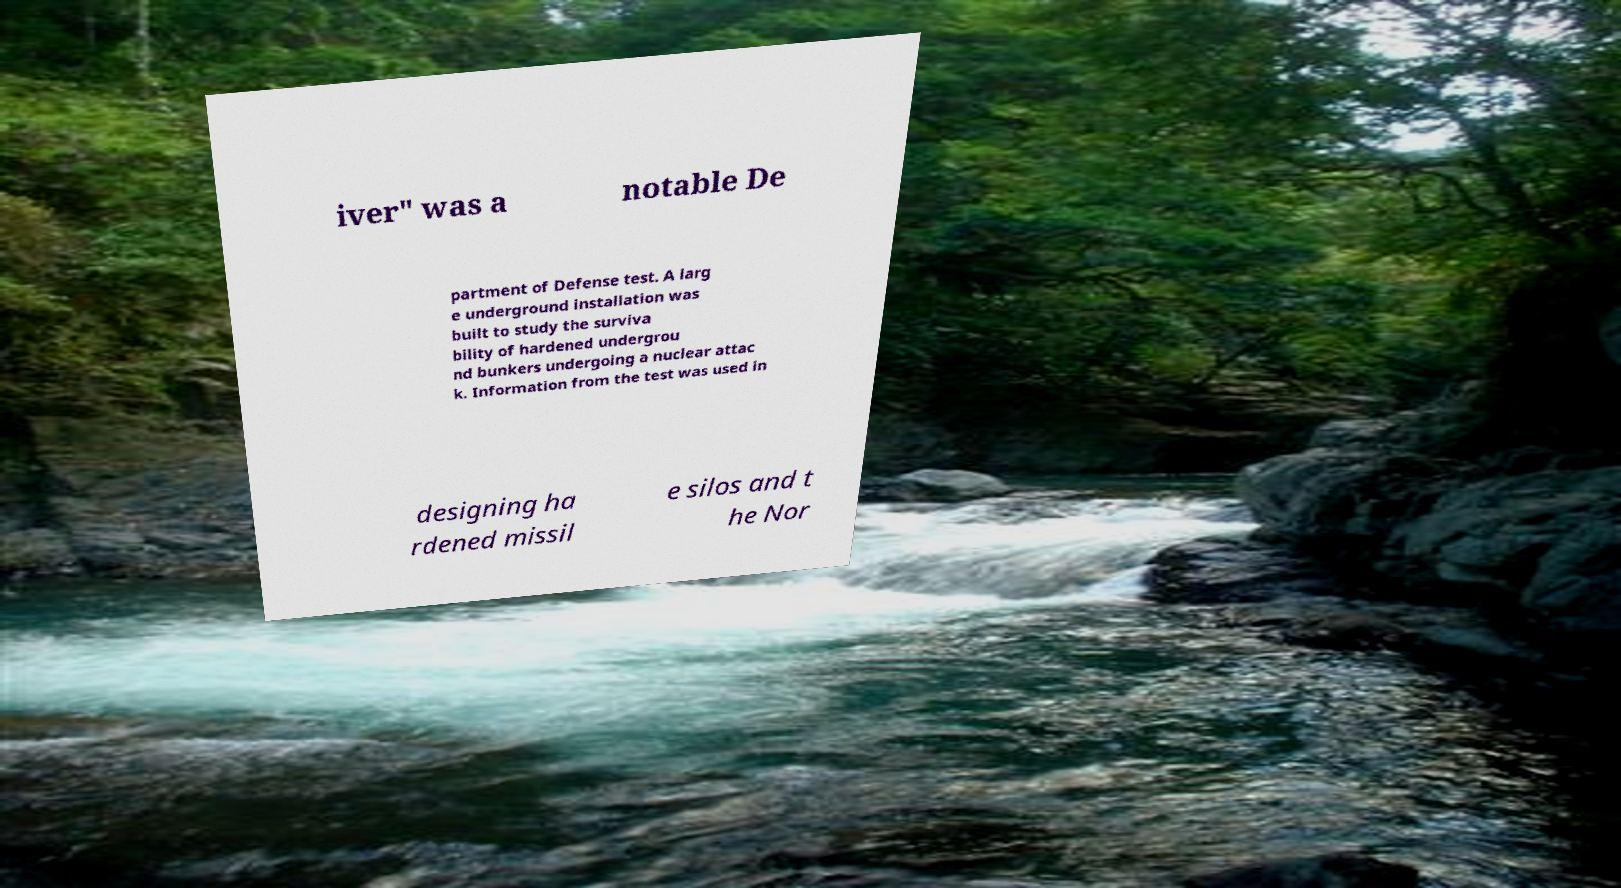There's text embedded in this image that I need extracted. Can you transcribe it verbatim? iver" was a notable De partment of Defense test. A larg e underground installation was built to study the surviva bility of hardened undergrou nd bunkers undergoing a nuclear attac k. Information from the test was used in designing ha rdened missil e silos and t he Nor 